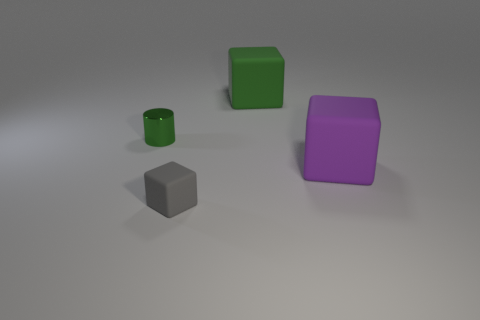What is the cube that is in front of the green rubber thing and to the left of the purple thing made of?
Offer a terse response. Rubber. Are there any small cubes that are to the left of the object behind the cylinder?
Provide a succinct answer. Yes. Does the gray block have the same material as the big green block?
Offer a terse response. Yes. There is a matte object that is in front of the large green thing and to the left of the large purple cube; what shape is it?
Your answer should be very brief. Cube. There is a rubber cube that is behind the cube that is on the right side of the green matte object; what size is it?
Offer a very short reply. Large. How many green objects have the same shape as the large purple thing?
Offer a very short reply. 1. Is there any other thing that is the same shape as the small metallic thing?
Keep it short and to the point. No. Are there any big matte blocks of the same color as the tiny cylinder?
Give a very brief answer. Yes. Does the green object that is left of the small gray thing have the same material as the cube that is to the right of the green rubber object?
Ensure brevity in your answer.  No. The tiny shiny cylinder has what color?
Ensure brevity in your answer.  Green. 